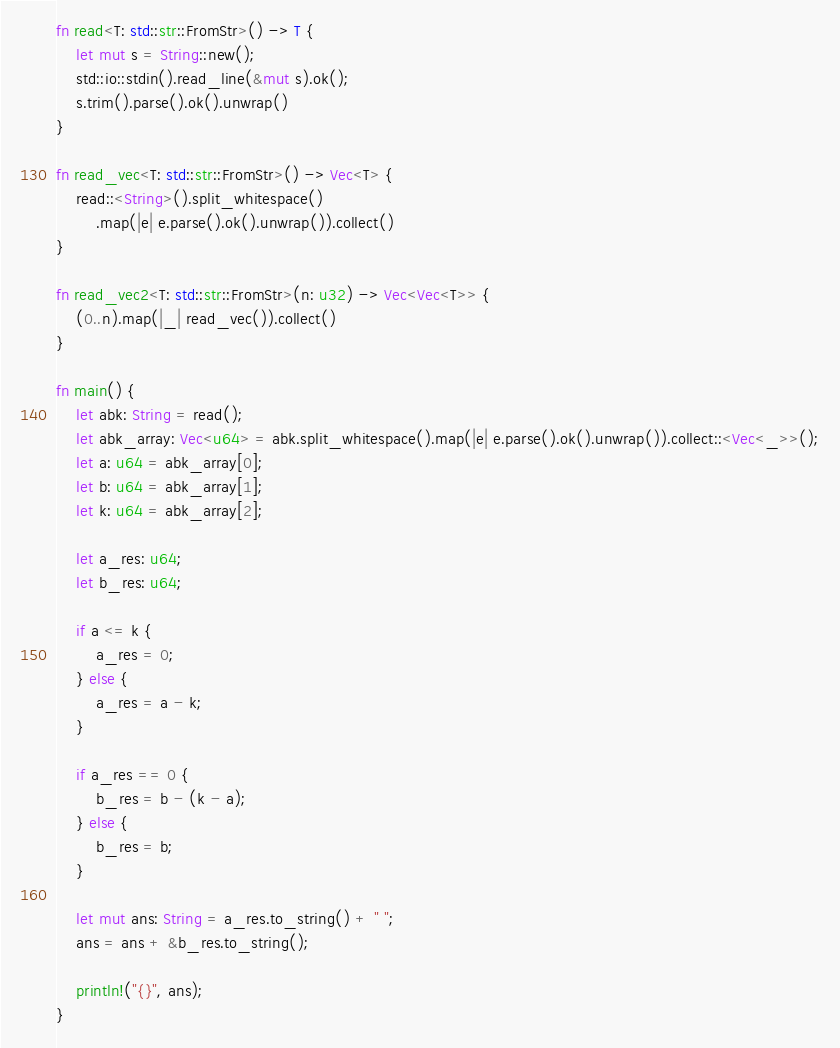<code> <loc_0><loc_0><loc_500><loc_500><_Rust_>fn read<T: std::str::FromStr>() -> T {
    let mut s = String::new();
    std::io::stdin().read_line(&mut s).ok();
    s.trim().parse().ok().unwrap()
}

fn read_vec<T: std::str::FromStr>() -> Vec<T> {
    read::<String>().split_whitespace()
        .map(|e| e.parse().ok().unwrap()).collect()
}

fn read_vec2<T: std::str::FromStr>(n: u32) -> Vec<Vec<T>> {
    (0..n).map(|_| read_vec()).collect()
}

fn main() {
    let abk: String = read();
    let abk_array: Vec<u64> = abk.split_whitespace().map(|e| e.parse().ok().unwrap()).collect::<Vec<_>>();
    let a: u64 = abk_array[0];
    let b: u64 = abk_array[1];
    let k: u64 = abk_array[2];

    let a_res: u64;
    let b_res: u64;

    if a <= k {
        a_res = 0;
    } else {
        a_res = a - k;
    }

    if a_res == 0 {
        b_res = b - (k - a);
    } else {
        b_res = b;
    }

    let mut ans: String = a_res.to_string() + " ";
    ans = ans + &b_res.to_string();

    println!("{}", ans);
}</code> 